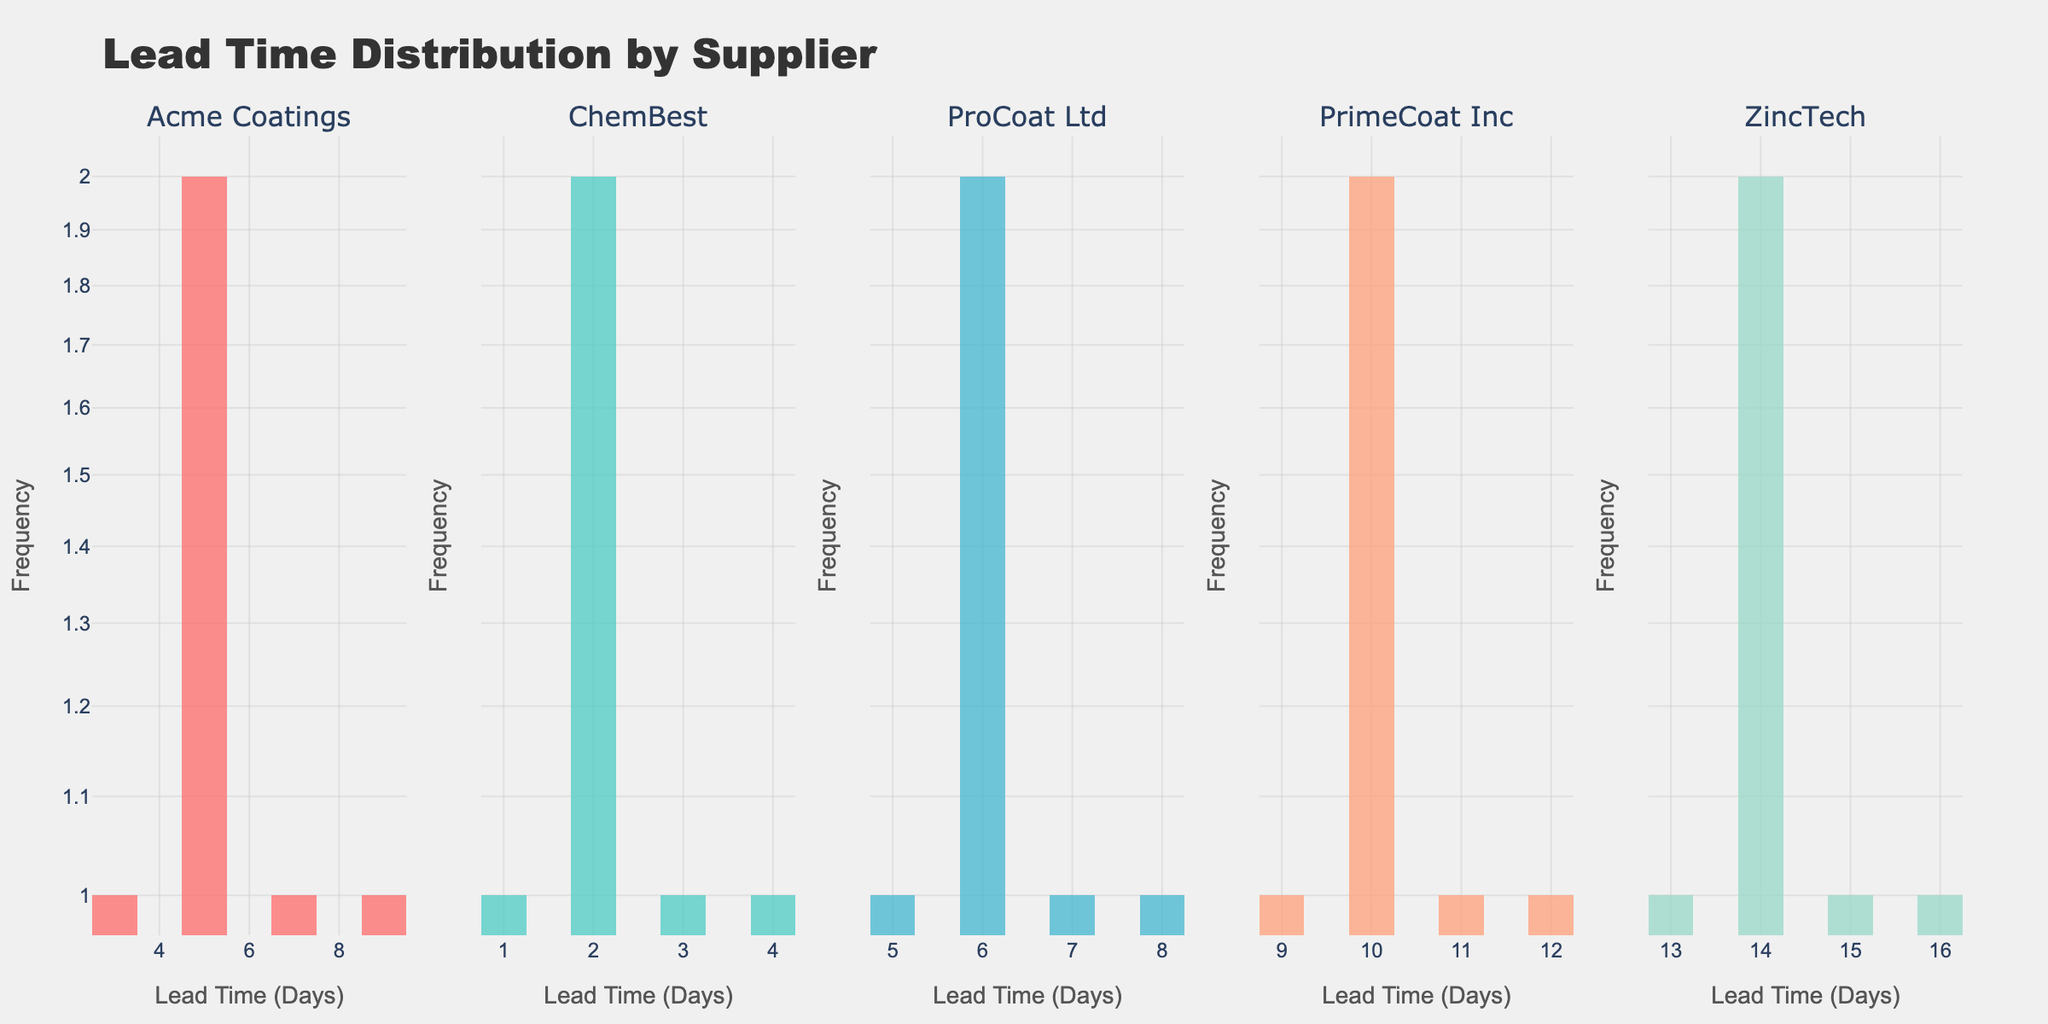What's the title of the plot? The title is located at the top of the figure and reads, "Lead Time Distribution by Supplier".
Answer: Lead Time Distribution by Supplier Which supplier has the highest maximum lead time? The histogram for ZincTech shows lead times up to 16 days, which is higher than the maximum lead times of other suppliers.
Answer: ZincTech What is the y-axis scale of the plot? The y-axis uses a log scale across all subplots, as indicated by the numbers and the axis type "log".
Answer: Log scale Which supplier has the smallest minimum lead time? The histogram for ChemBest shows lead times starting from 1 day, while other suppliers have higher starting points.
Answer: ChemBest Count how many suppliers have their maximum lead times above 10 days. By inspecting the subplots, PrimeCoat Inc. and ZincTech have maximum lead times above 10 days, with values reaching 12 and 16 days respectively. Hence, two suppliers meet this condition.
Answer: 2 What is the range of lead times for ProCoat Ltd? The histogram for ProCoat Ltd shows lead times ranging from 5 to 8 days. Subtracting the minimum from the maximum gives the range as 8 - 5.
Answer: 3 Which supplier has the most frequent lead time for PrimeCoat Inc? The histogram for PrimeCoat Inc shows that the bars corresponding to 10 days appear more frequently than the others.
Answer: 10 days How does the frequency of lead times for Acme Coatings at 5 days compare to lead times for ChemBest at 2 days? The histogram shows that Acme Coatings has 2 occurrences at 5 days, while ChemBest has 2 occurrences at 2 days, meaning they have the same frequency for these lead times.
Answer: Same frequency Which subplot uses a color mix of red and green? By referring to the colors used, the subplot for Acme Coatings uses a red color and ChemBest uses green.
Answer: None Does any supplier outperform the others in terms of consistently low lead times? ChemBest consistently has the lowest lead times, with most lead times between 1 and 3 days.
Answer: ChemBest 